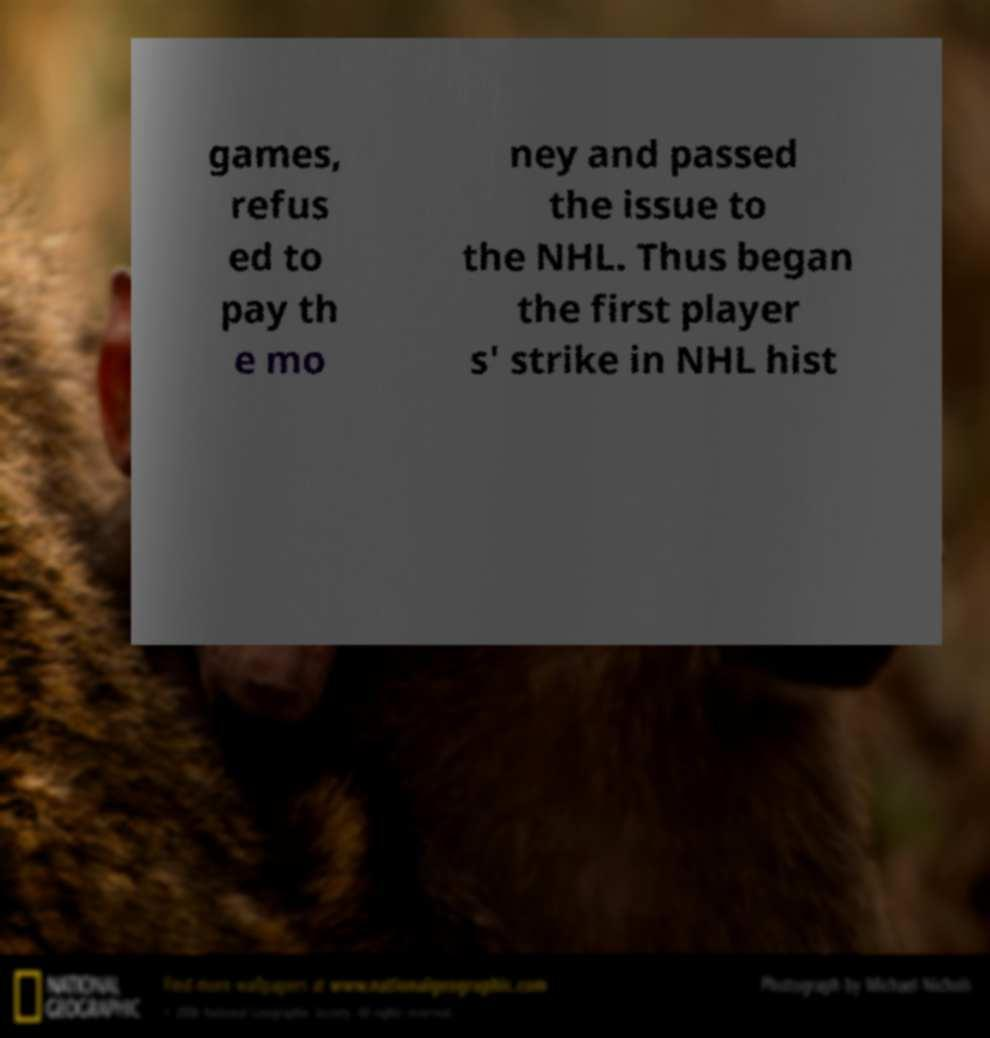For documentation purposes, I need the text within this image transcribed. Could you provide that? games, refus ed to pay th e mo ney and passed the issue to the NHL. Thus began the first player s' strike in NHL hist 